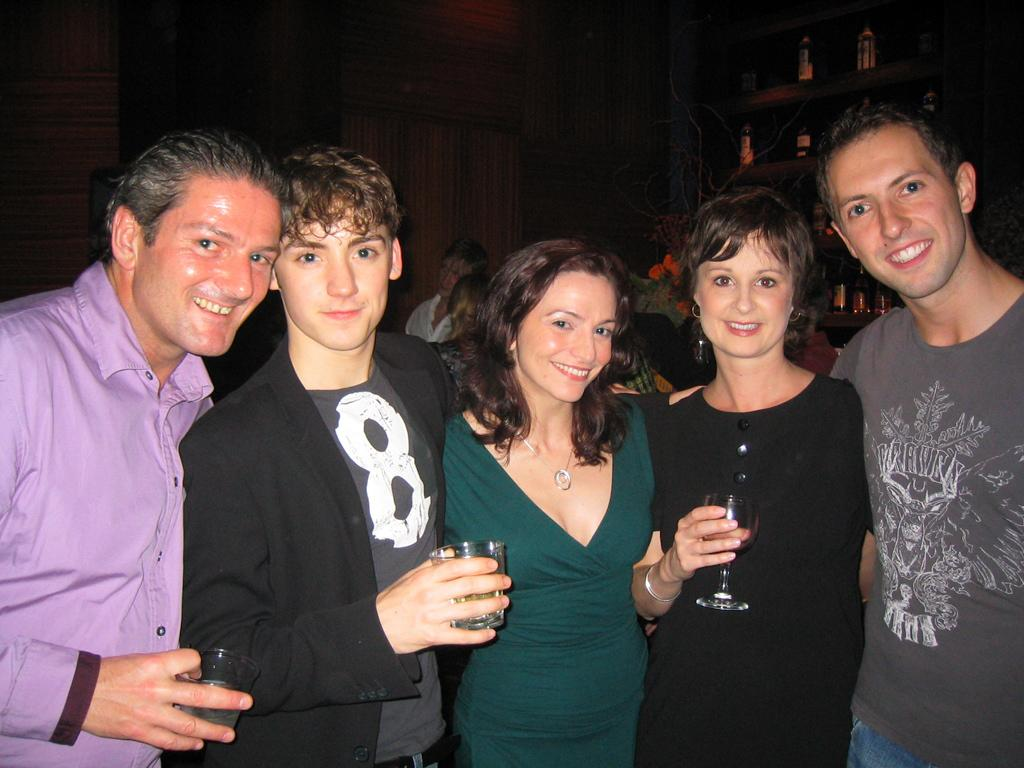What is happening with the group of people in the image? The people in the image are standing and smiling. What are the people holding in their hands? The people are holding glasses in their hands. Can you describe the background of the image? There are bottles in a cupboard in the background, and there is another group of people in the background. What is the chance of the spade being used in the image? There is no spade present in the image, so it is not possible to determine the chance of it being used. 